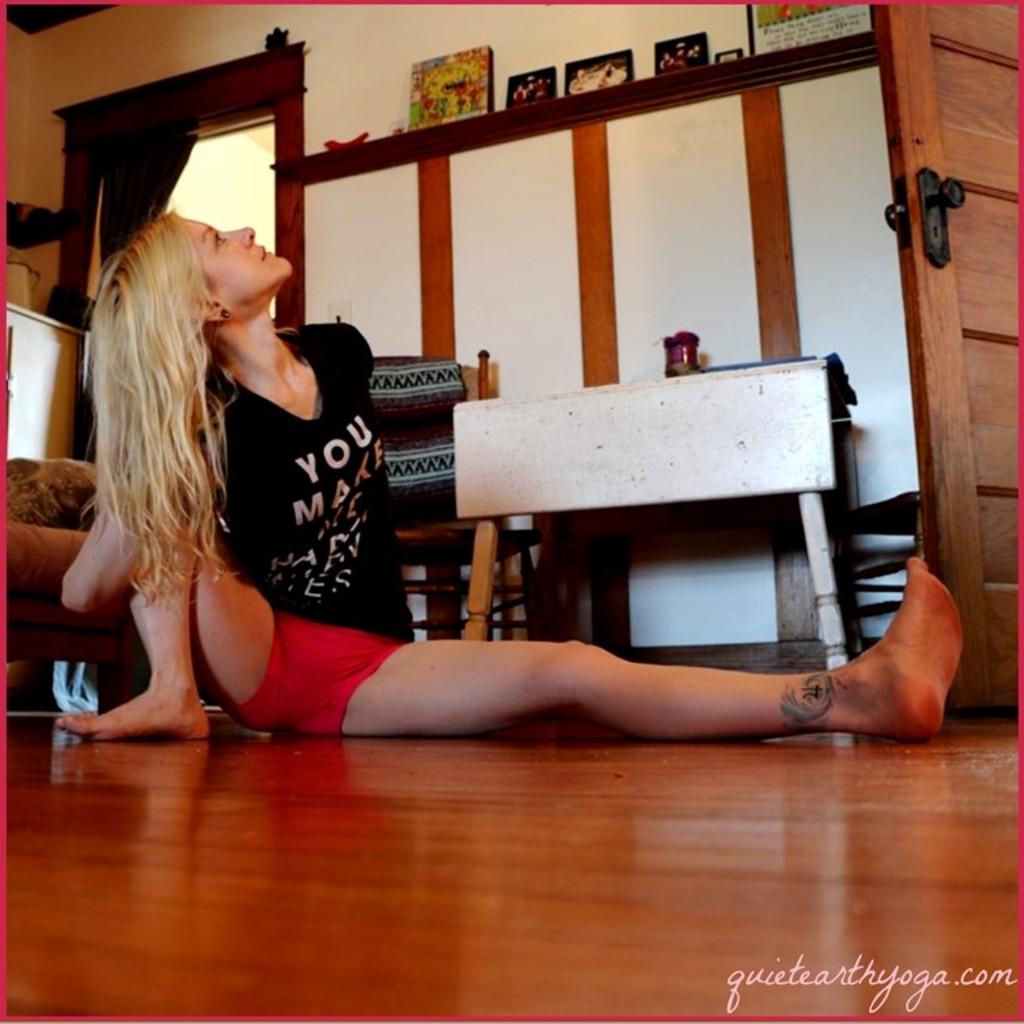What is the top word on her shirt?
Give a very brief answer. You. 